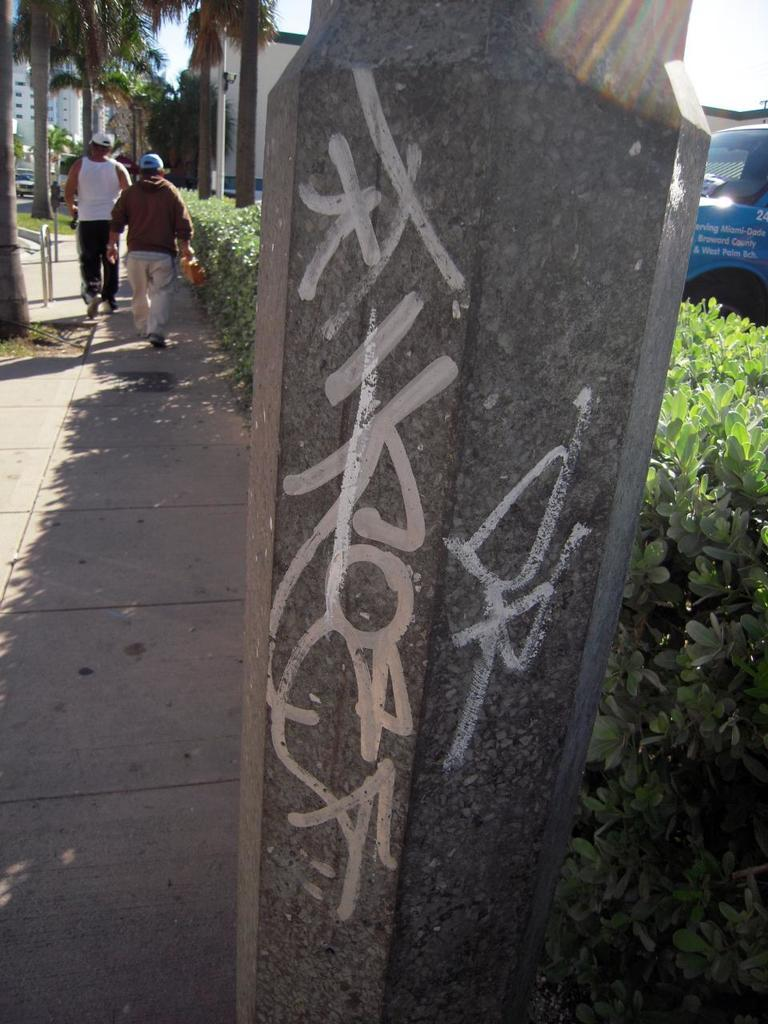What is the main object in the image? There is a pole in the image. How many people are present in the image? There are two persons standing in the image. What else can be seen in the image besides the pole and people? There are vehicles, plants, and trees in the image. What type of leather is being used to make the cable in the image? There is no leather or cable present in the image. 